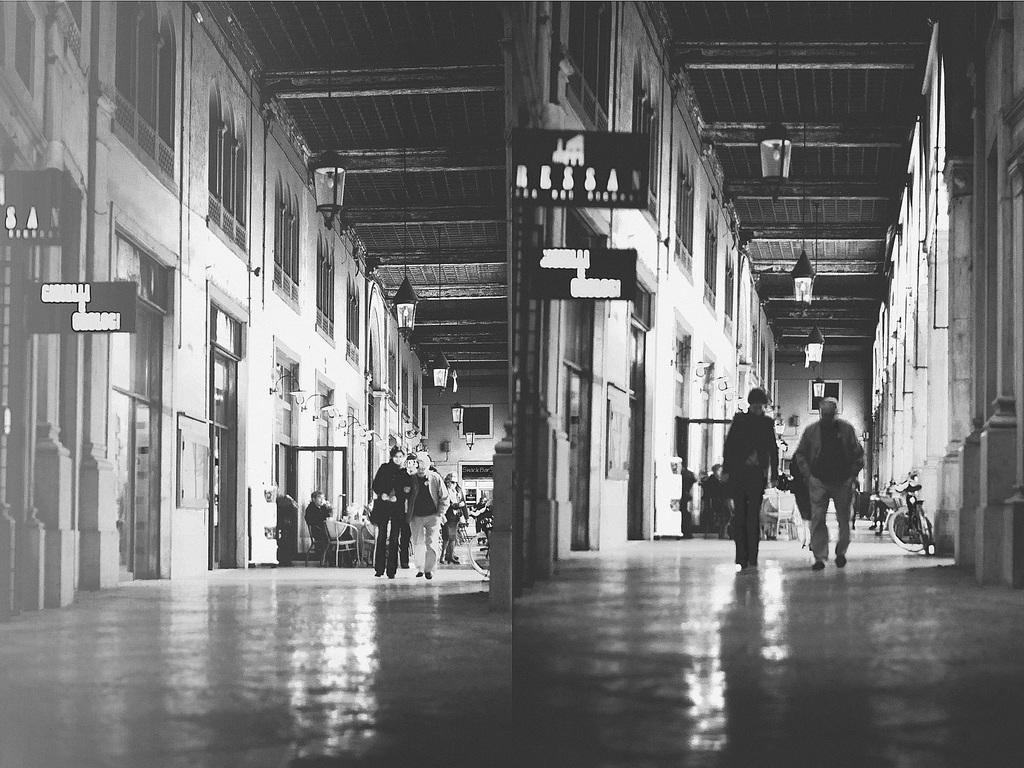What are the people in the image doing? The people in the image are walking. What else can be seen in the image besides people walking? There are sign boards and a bicycle on the right side of the image. Where is the door located in the image? The door is on the left side of the image. What time of day is it in the image, considering the presence of the afternoon? The provided facts do not mention the time of day or the presence of the afternoon, so it cannot be determined from the image. 